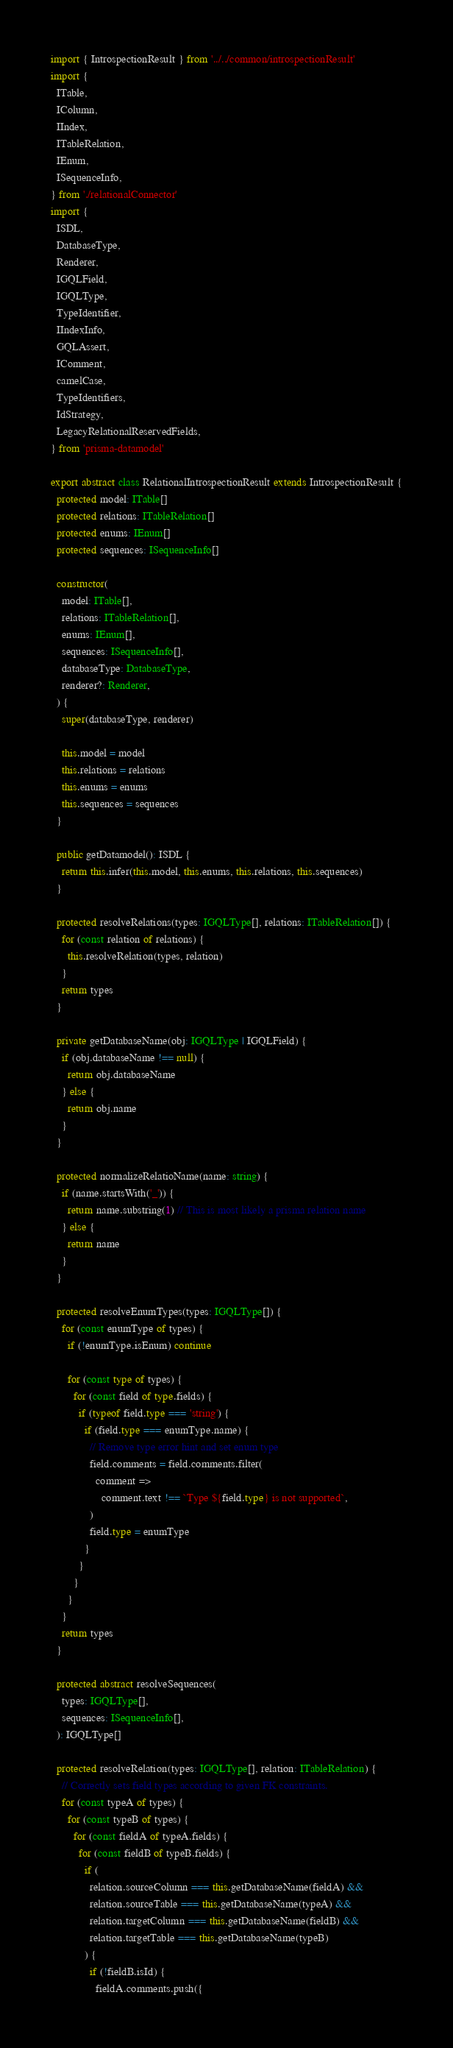Convert code to text. <code><loc_0><loc_0><loc_500><loc_500><_TypeScript_>import { IntrospectionResult } from '../../common/introspectionResult'
import {
  ITable,
  IColumn,
  IIndex,
  ITableRelation,
  IEnum,
  ISequenceInfo,
} from './relationalConnector'
import {
  ISDL,
  DatabaseType,
  Renderer,
  IGQLField,
  IGQLType,
  TypeIdentifier,
  IIndexInfo,
  GQLAssert,
  IComment,
  camelCase,
  TypeIdentifiers,
  IdStrategy,
  LegacyRelationalReservedFields,
} from 'prisma-datamodel'

export abstract class RelationalIntrospectionResult extends IntrospectionResult {
  protected model: ITable[]
  protected relations: ITableRelation[]
  protected enums: IEnum[]
  protected sequences: ISequenceInfo[]

  constructor(
    model: ITable[],
    relations: ITableRelation[],
    enums: IEnum[],
    sequences: ISequenceInfo[],
    databaseType: DatabaseType,
    renderer?: Renderer,
  ) {
    super(databaseType, renderer)

    this.model = model
    this.relations = relations
    this.enums = enums
    this.sequences = sequences
  }

  public getDatamodel(): ISDL {
    return this.infer(this.model, this.enums, this.relations, this.sequences)
  }

  protected resolveRelations(types: IGQLType[], relations: ITableRelation[]) {
    for (const relation of relations) {
      this.resolveRelation(types, relation)
    }
    return types
  }

  private getDatabaseName(obj: IGQLType | IGQLField) {
    if (obj.databaseName !== null) {
      return obj.databaseName
    } else {
      return obj.name
    }
  }

  protected normalizeRelatioName(name: string) {
    if (name.startsWith('_')) {
      return name.substring(1) // This is most likely a prisma relation name
    } else {
      return name
    }
  }

  protected resolveEnumTypes(types: IGQLType[]) {
    for (const enumType of types) {
      if (!enumType.isEnum) continue

      for (const type of types) {
        for (const field of type.fields) {
          if (typeof field.type === 'string') {
            if (field.type === enumType.name) {
              // Remove type error hint and set enum type
              field.comments = field.comments.filter(
                comment =>
                  comment.text !== `Type ${field.type} is not supported`,
              )
              field.type = enumType
            }
          }
        }
      }
    }
    return types
  }

  protected abstract resolveSequences(
    types: IGQLType[],
    sequences: ISequenceInfo[],
  ): IGQLType[]

  protected resolveRelation(types: IGQLType[], relation: ITableRelation) {
    // Correctly sets field types according to given FK constraints.
    for (const typeA of types) {
      for (const typeB of types) {
        for (const fieldA of typeA.fields) {
          for (const fieldB of typeB.fields) {
            if (
              relation.sourceColumn === this.getDatabaseName(fieldA) &&
              relation.sourceTable === this.getDatabaseName(typeA) &&
              relation.targetColumn === this.getDatabaseName(fieldB) &&
              relation.targetTable === this.getDatabaseName(typeB)
            ) {
              if (!fieldB.isId) {
                fieldA.comments.push({</code> 